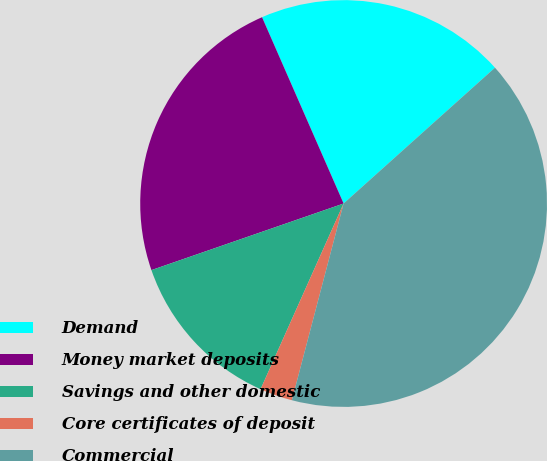Convert chart to OTSL. <chart><loc_0><loc_0><loc_500><loc_500><pie_chart><fcel>Demand<fcel>Money market deposits<fcel>Savings and other domestic<fcel>Core certificates of deposit<fcel>Commercial<nl><fcel>19.93%<fcel>23.74%<fcel>13.0%<fcel>2.6%<fcel>40.73%<nl></chart> 